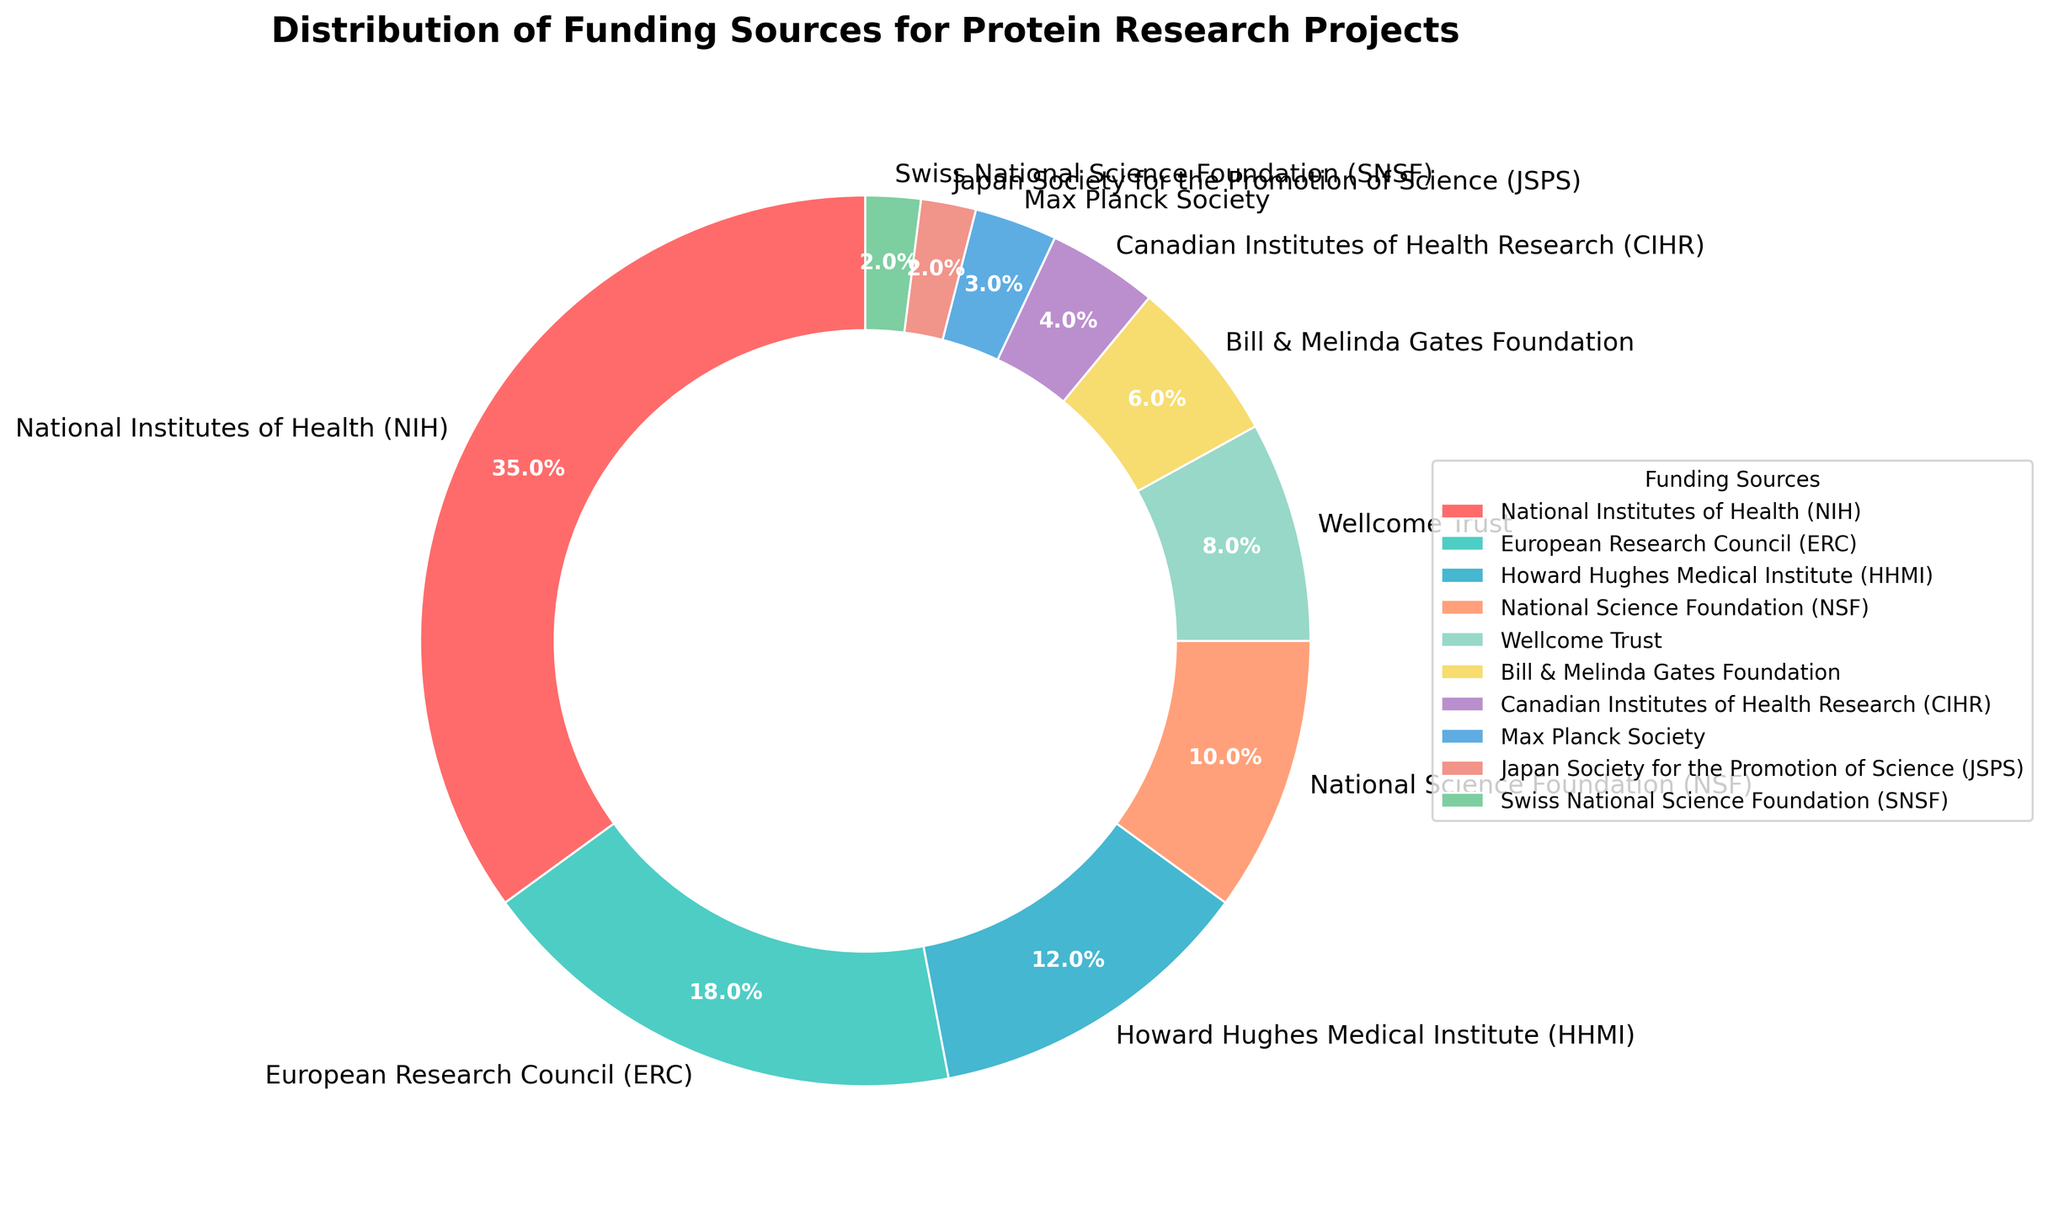What percentage of funding comes from the top three sources? The top three funding sources are National Institutes of Health (35%), European Research Council (18%), and Howard Hughes Medical Institute (12%). Adding these percentages together, we get 35 + 18 + 12 = 65%
Answer: 65% Which funding source provides the smallest percentage? The smallest percentage is provided by the Japan Society for the Promotion of Science (JSPS) and the Swiss National Science Foundation (SNSF), each contributing 2%.
Answer: JSPS and SNSF How much more funding does the National Institutes of Health (NIH) provide compared to the Bill & Melinda Gates Foundation? The NIH provides 35%, and the Bill & Melinda Gates Foundation provides 6%. The difference is 35 - 6 = 29%.
Answer: 29% Which funding source contributes more: the National Science Foundation (NSF) or the Wellcome Trust? The National Science Foundation contributes 10%, whereas the Wellcome Trust contributes 8%. Comparing these, 10% > 8%, so the NSF contributes more.
Answer: National Science Foundation (NSF) Are there more funding sources contributing less than 10% or more than 10% to the overall funding? Listing the sources contributing less than 10%: Howard Hughes Medical Institute (12%), National Science Foundation (10%). 
Listing the sources contributing more than 10%: Wellcome Trust (8%), Bill & Melinda Gates Foundation (6%), Canadian Institutes of Health Research (4%), Max Planck Society (3%), Japan Society for the Promotion of Science (2%), Swiss National Science Foundation (2%).
There are 2 sources contributing more than 10% and 6 sources contributing less than 10%.
Answer: Less than 10% Which funding sources are represented in shades of blue or green? The colors corresponding to the funding sources are: European Research Council (green), Howard Hughes Medical Institute (blue), National Science Foundation (green), Wellcome Trust (blue), Canadian Institutes of Health Research (green). Therefore, ERC, NSF, and CIHR are shades of green, while HHMI and Wellcome Trust are shades of blue.
Answer: ERC, HHMI, NSF, Wellcome Trust, CIHR Which funding source is placed directly on the right side of the pie chart? The pie chart starts at the top (12 o'clock) and goes clockwise. The National Institutes of Health (NIH) takes the top position followed by the European Research Council (ERC). Therefore, ERC is placed directly on the right side.
Answer: European Research Council (ERC) 